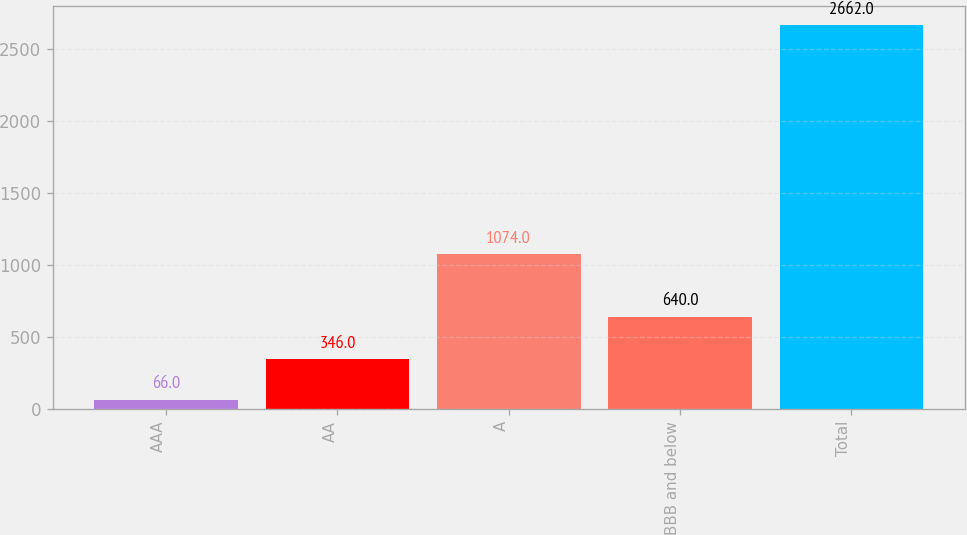Convert chart. <chart><loc_0><loc_0><loc_500><loc_500><bar_chart><fcel>AAA<fcel>AA<fcel>A<fcel>BBB and below<fcel>Total<nl><fcel>66<fcel>346<fcel>1074<fcel>640<fcel>2662<nl></chart> 